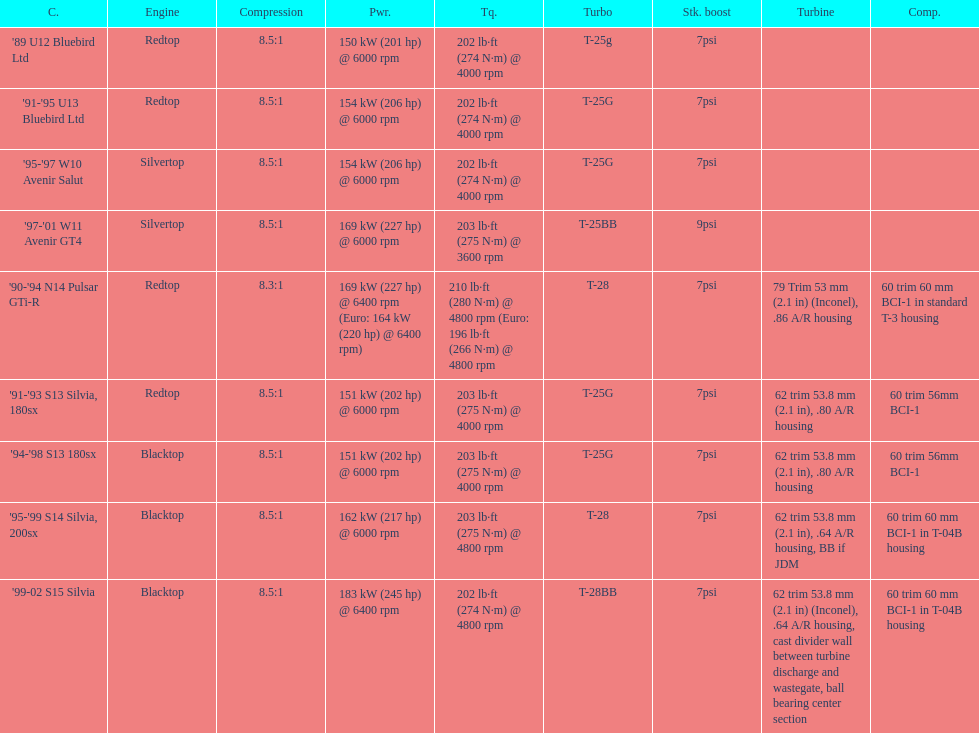Which engine(s) has the least amount of power? Redtop. 